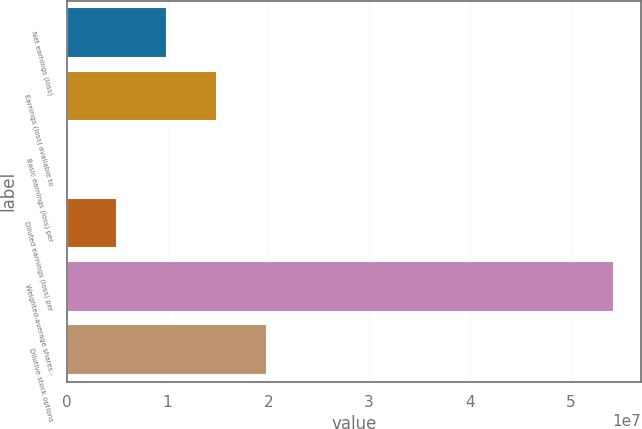Convert chart to OTSL. <chart><loc_0><loc_0><loc_500><loc_500><bar_chart><fcel>Net earnings (loss)<fcel>Earnings (loss) available to<fcel>Basic earnings (loss) per<fcel>Diluted earnings (loss) per<fcel>Weighted-average shares -<fcel>Dilutive stock options<nl><fcel>9.94249e+06<fcel>1.49137e+07<fcel>1.05<fcel>4.97124e+06<fcel>5.42927e+07<fcel>1.9885e+07<nl></chart> 